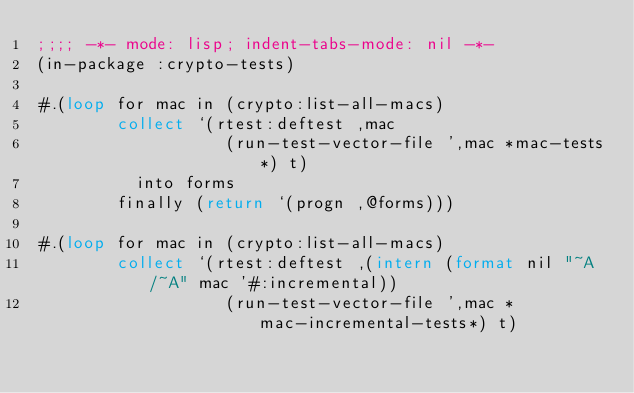<code> <loc_0><loc_0><loc_500><loc_500><_Lisp_>;;;; -*- mode: lisp; indent-tabs-mode: nil -*-
(in-package :crypto-tests)

#.(loop for mac in (crypto:list-all-macs)
        collect `(rtest:deftest ,mac
                   (run-test-vector-file ',mac *mac-tests*) t)
          into forms
        finally (return `(progn ,@forms)))

#.(loop for mac in (crypto:list-all-macs)
        collect `(rtest:deftest ,(intern (format nil "~A/~A" mac '#:incremental))
                   (run-test-vector-file ',mac *mac-incremental-tests*) t)</code> 